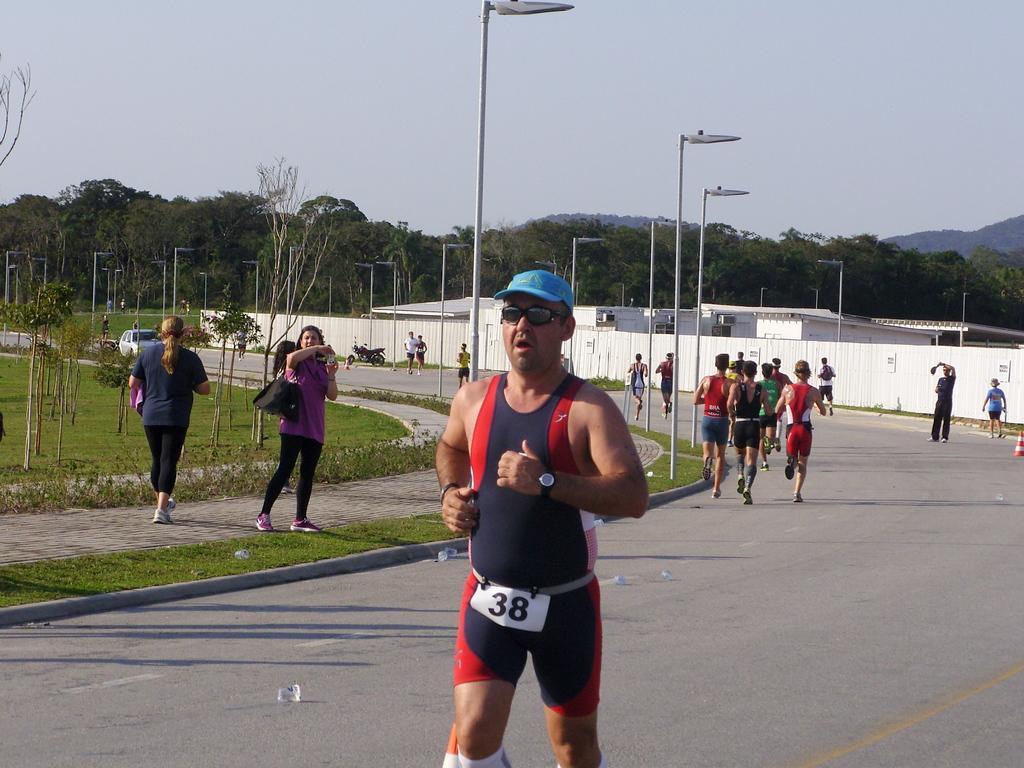In one or two sentences, can you explain what this image depicts? In this image I can see group of people running. In front the person is wearing black and red color dress, background I can see few light poles and I can see few sheds in white color, trees in green color and the sky is in white color. 